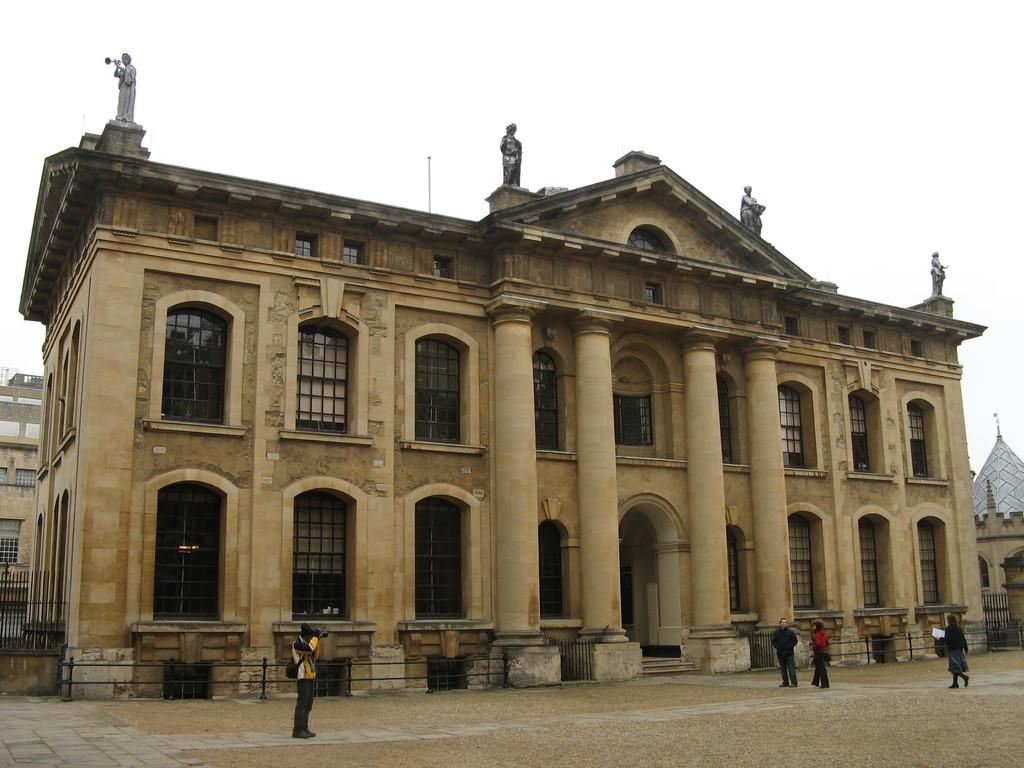What type of structures can be seen in the image? There are buildings in the image. Are there any decorative elements on the buildings? Yes, there are sculptures on top of a building. How many people are present in the image? Four persons are standing in front of the building. What can be seen in the background of the image? The sky is visible in the background of the image. Can you tell me how many zebras are standing next to the building in the image? There are no zebras present in the image; it features buildings, sculptures, and people. What is the mindset of the sculptures on top of the building in the image? The mindset of the sculptures cannot be determined, as they are inanimate objects. 